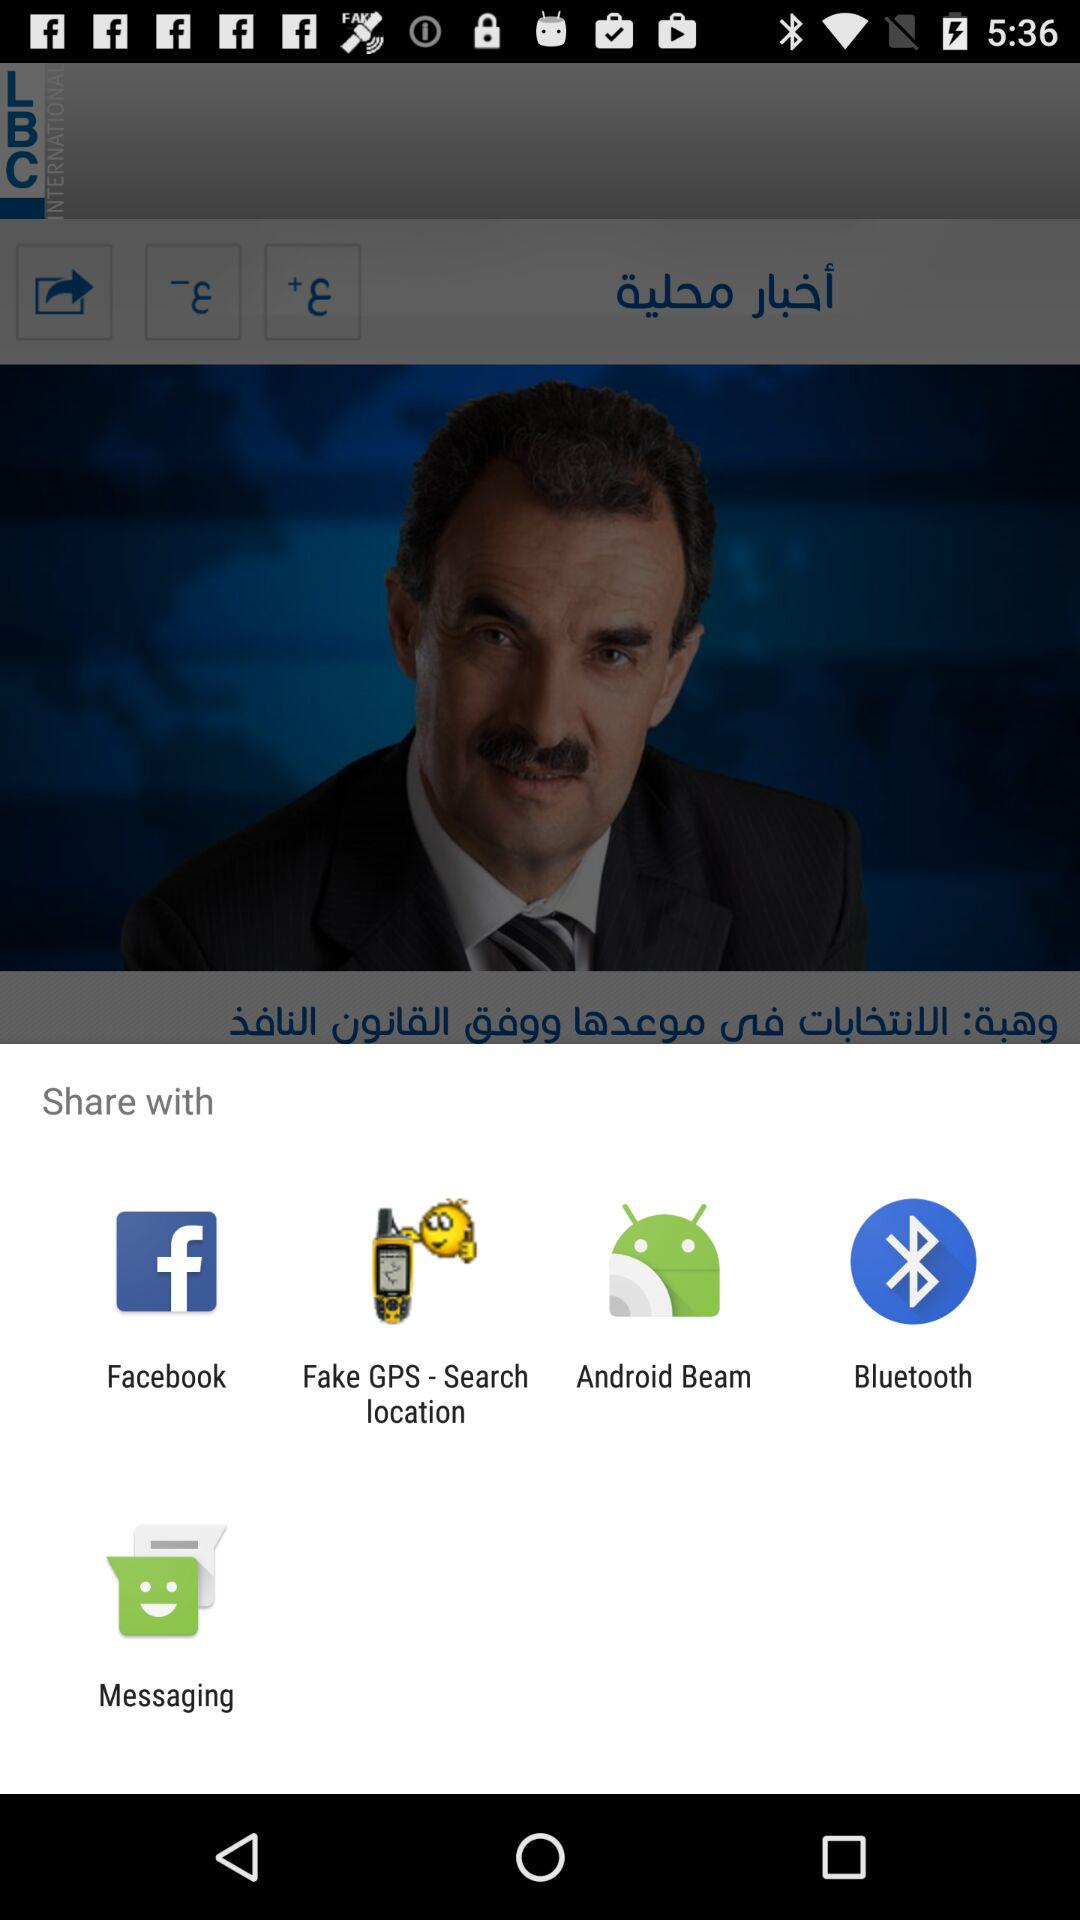What are the different applications with which we can share? The different applications with which we can share are "Facebook", "Fake GPS - Search location", "Android Beam", "Bluetooth" and "Messaging". 